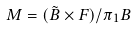Convert formula to latex. <formula><loc_0><loc_0><loc_500><loc_500>M = ( \tilde { B } \times F ) / \pi _ { 1 } B</formula> 